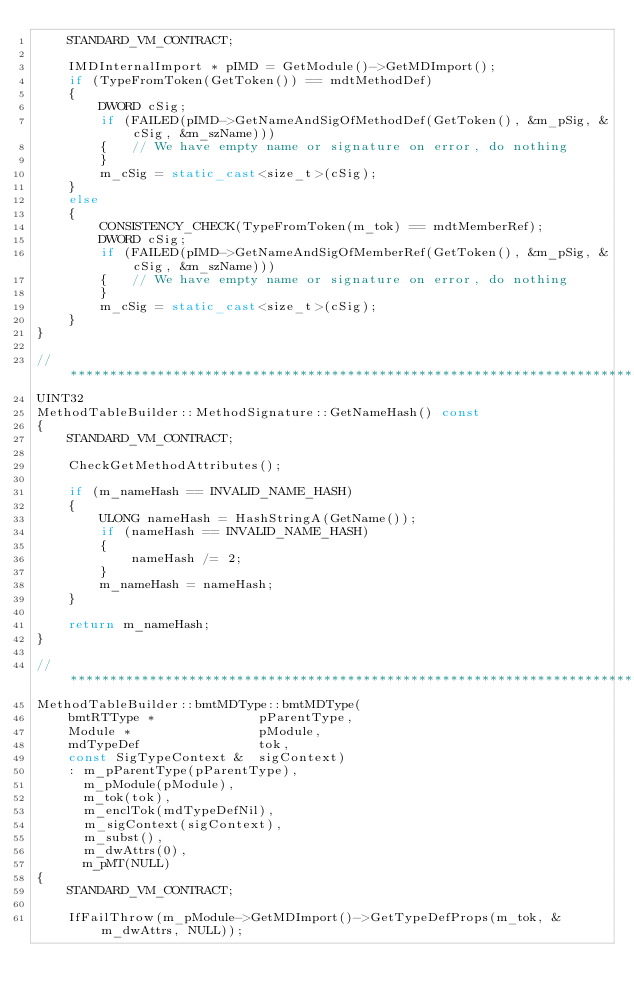<code> <loc_0><loc_0><loc_500><loc_500><_C++_>    STANDARD_VM_CONTRACT;

    IMDInternalImport * pIMD = GetModule()->GetMDImport();
    if (TypeFromToken(GetToken()) == mdtMethodDef)
    {
        DWORD cSig;
        if (FAILED(pIMD->GetNameAndSigOfMethodDef(GetToken(), &m_pSig, &cSig, &m_szName)))
        {   // We have empty name or signature on error, do nothing
        }
        m_cSig = static_cast<size_t>(cSig);
    }
    else
    {
        CONSISTENCY_CHECK(TypeFromToken(m_tok) == mdtMemberRef);
        DWORD cSig;
        if (FAILED(pIMD->GetNameAndSigOfMemberRef(GetToken(), &m_pSig, &cSig, &m_szName)))
        {   // We have empty name or signature on error, do nothing
        }
        m_cSig = static_cast<size_t>(cSig);
    }
}

//*******************************************************************************
UINT32
MethodTableBuilder::MethodSignature::GetNameHash() const
{
    STANDARD_VM_CONTRACT;

    CheckGetMethodAttributes();

    if (m_nameHash == INVALID_NAME_HASH)
    {
        ULONG nameHash = HashStringA(GetName());
        if (nameHash == INVALID_NAME_HASH)
        {
            nameHash /= 2;
        }
        m_nameHash = nameHash;
    }

    return m_nameHash;
}

//*******************************************************************************
MethodTableBuilder::bmtMDType::bmtMDType(
    bmtRTType *             pParentType,
    Module *                pModule,
    mdTypeDef               tok,
    const SigTypeContext &  sigContext)
    : m_pParentType(pParentType),
      m_pModule(pModule),
      m_tok(tok),
      m_enclTok(mdTypeDefNil),
      m_sigContext(sigContext),
      m_subst(),
      m_dwAttrs(0),
      m_pMT(NULL)
{
    STANDARD_VM_CONTRACT;

    IfFailThrow(m_pModule->GetMDImport()->GetTypeDefProps(m_tok, &m_dwAttrs, NULL));
</code> 